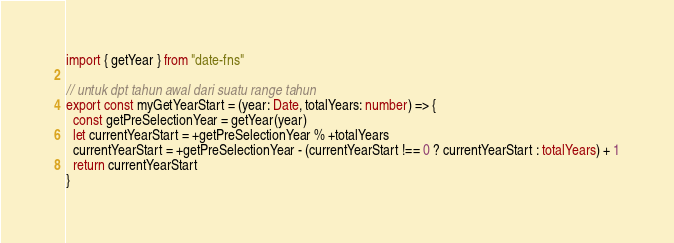Convert code to text. <code><loc_0><loc_0><loc_500><loc_500><_TypeScript_>import { getYear } from "date-fns"

// untuk dpt tahun awal dari suatu range tahun
export const myGetYearStart = (year: Date, totalYears: number) => {
  const getPreSelectionYear = getYear(year)
  let currentYearStart = +getPreSelectionYear % +totalYears
  currentYearStart = +getPreSelectionYear - (currentYearStart !== 0 ? currentYearStart : totalYears) + 1
  return currentYearStart
}
</code> 